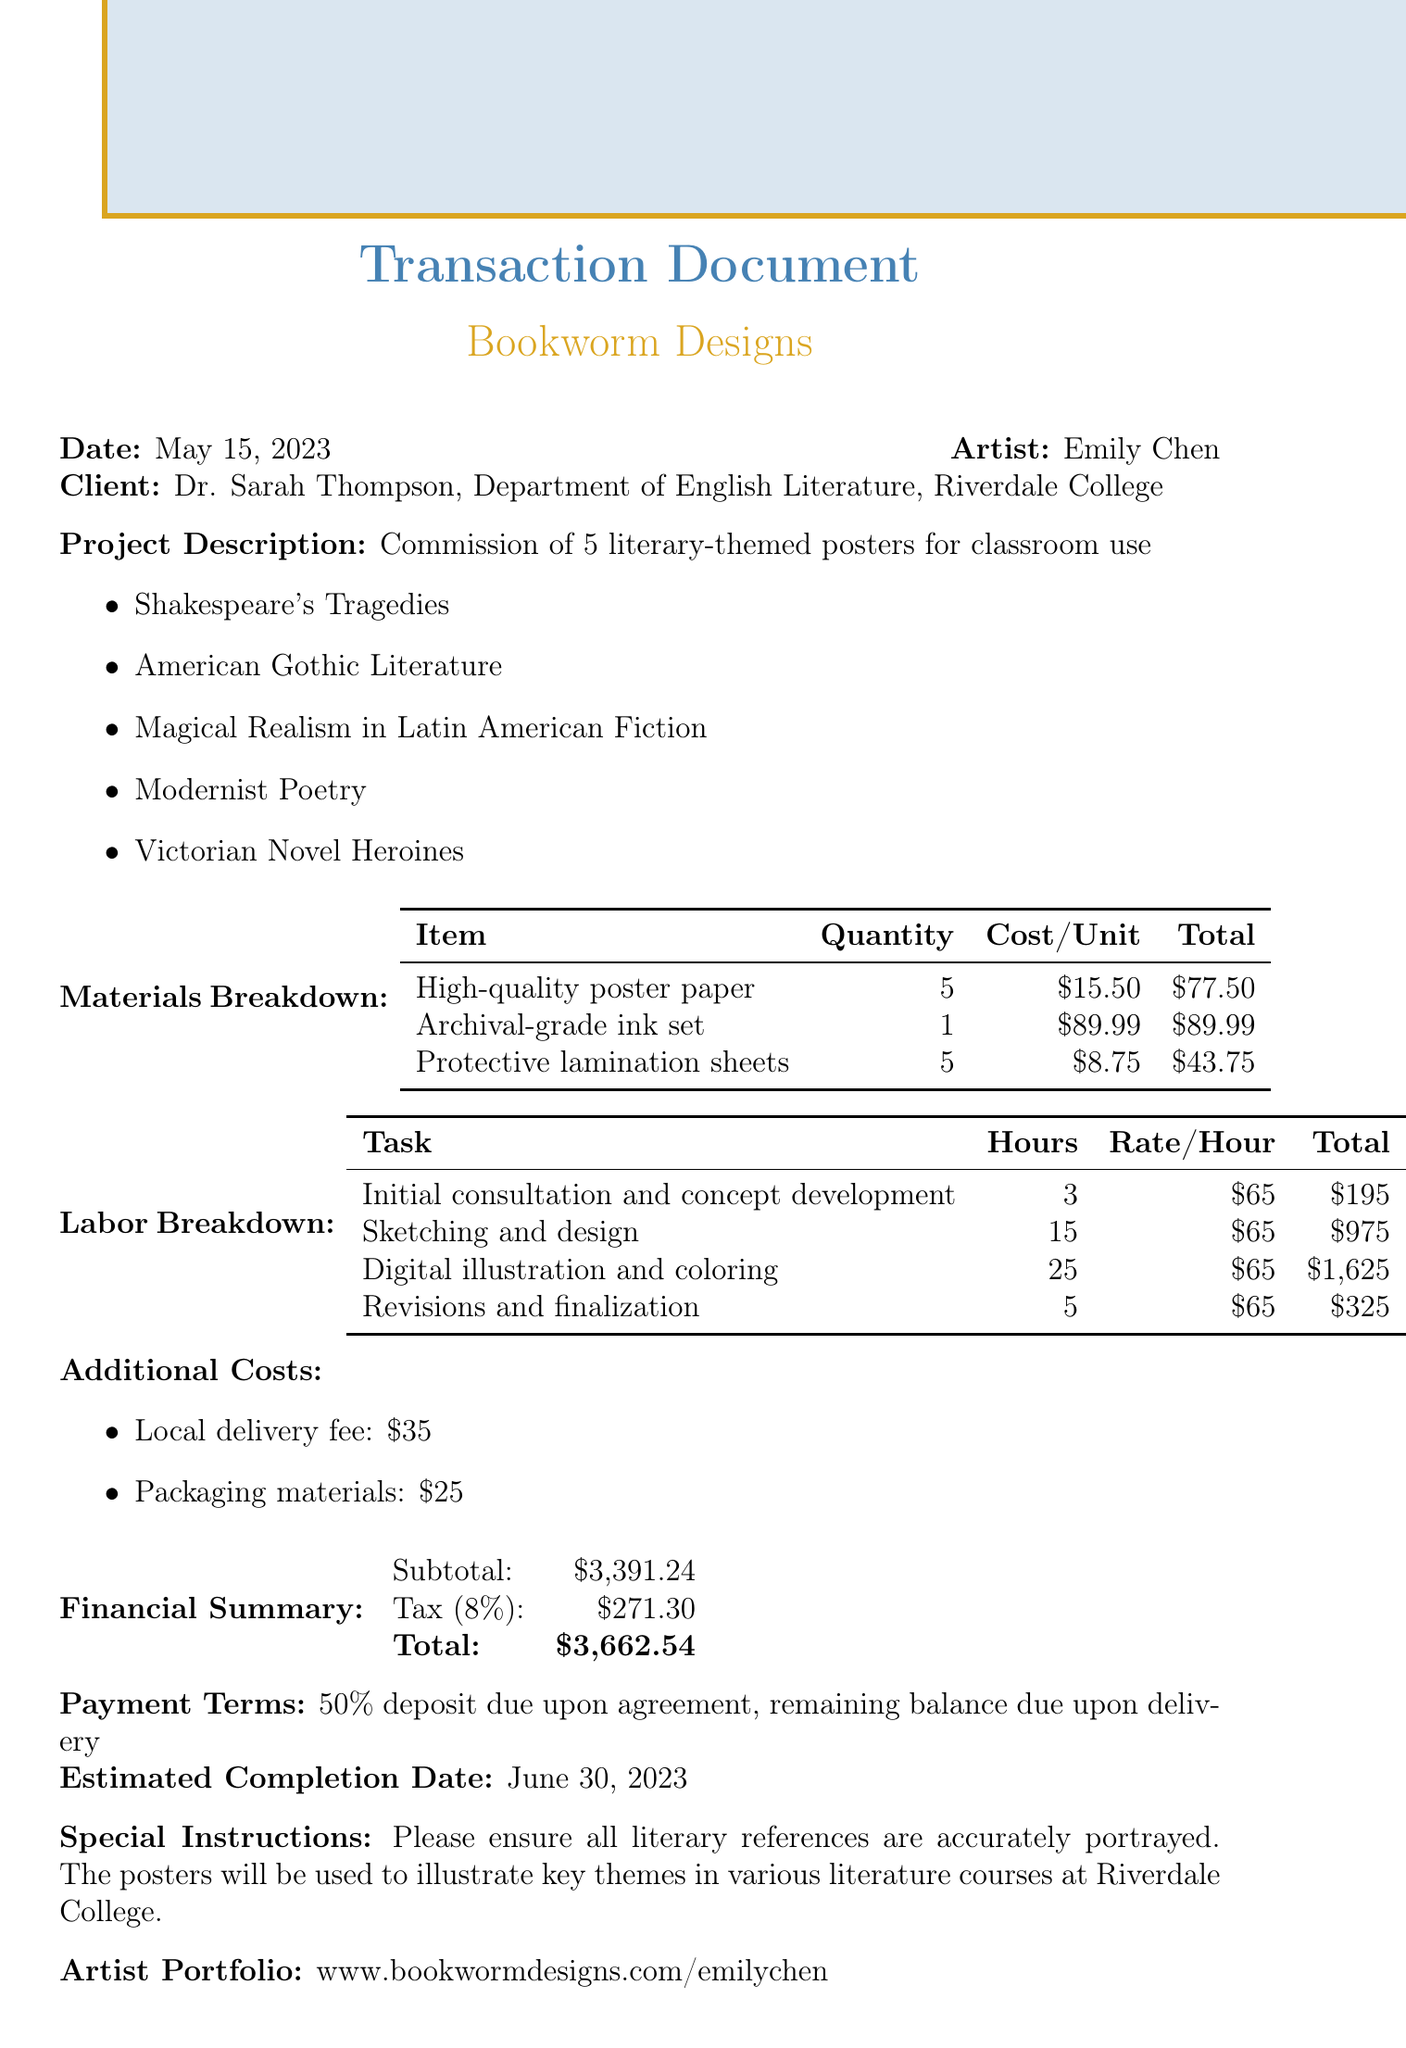What is the transaction date? The transaction date is clearly stated in the document.
Answer: 2023-05-15 Who is the artist commissioned for the project? The name of the artist is listed in the document.
Answer: Emily Chen What is the total amount due? The total amount is provided in the financial summary section of the document.
Answer: 3662.54 How many posters are being commissioned? The number of posters is noted in the project description.
Answer: 5 What is the tax rate applied to the transaction? The tax rate is specified in the financial summary portion of the document.
Answer: 0.08 What item had the highest cost in the materials breakdown? The total costs for each item in the materials breakdown provide a comparison for this answer.
Answer: Archival-grade ink set What is the payment term for the commission? The payment terms are described in a specific section of the document.
Answer: 50% deposit due upon agreement, remaining balance due upon delivery What is the estimated completion date for the project? The estimated completion date is mentioned explicitly in the document.
Answer: 2023-06-30 Which themes are included in the posters? The themes are listed under the project description in a bullet point format.
Answer: Shakespeare's Tragedies, American Gothic Literature, Magical Realism in Latin American Fiction, Modernist Poetry, Victorian Novel Heroines 